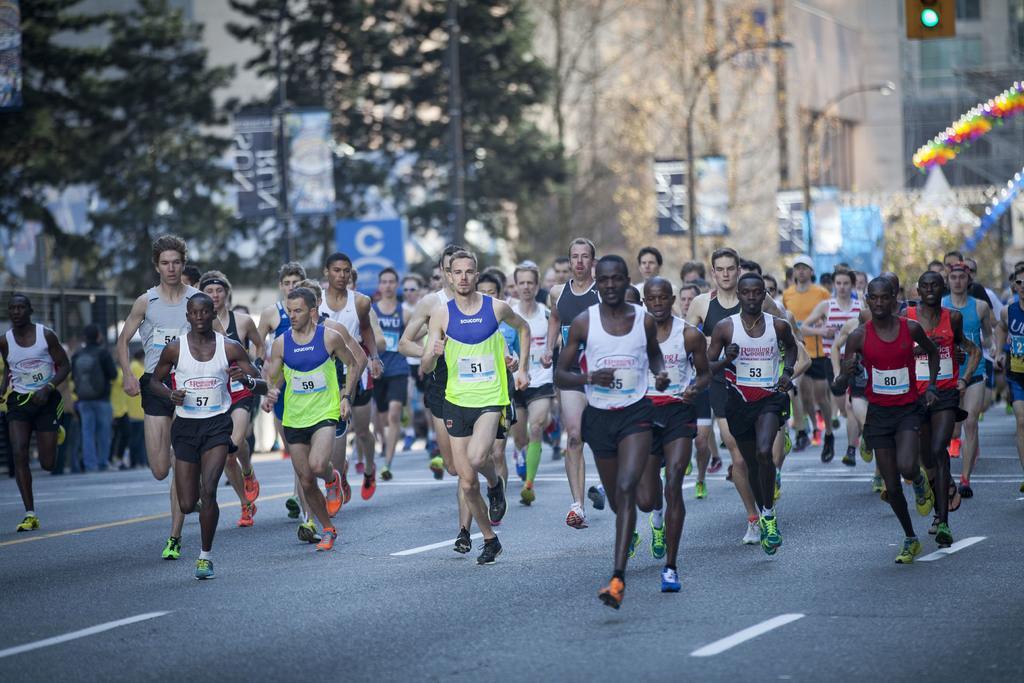Describe this image in one or two sentences. This picture is clicked outside the city. In this picture, we see many people are running on the road. Behind them, we see street lights, poles and trees. There are buildings in the background. On the right side, we see boards and lights in different colors. On the left side, we see a fence and boards in black and blue color with some text written on it. At the bottom,we see the road. This picture is blurred in the background. 